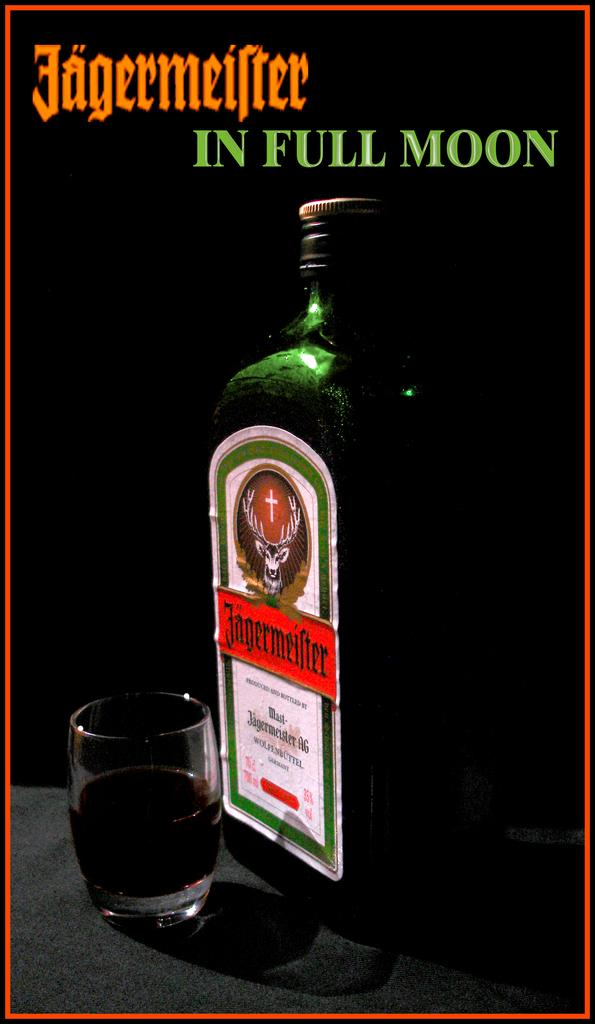Provide a one-sentence caption for the provided image. A bottle of jageemeister with a shot glass full of the alcohol. 